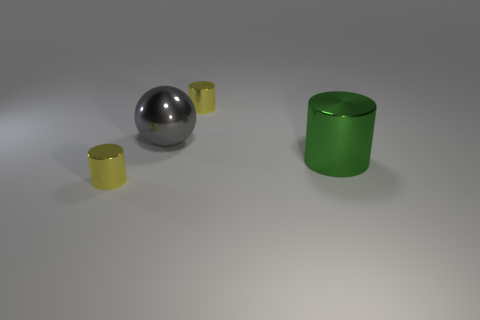Subtract all green spheres. Subtract all green cubes. How many spheres are left? 1 Add 1 tiny green matte cubes. How many objects exist? 5 Subtract all cylinders. How many objects are left? 1 Subtract 0 gray cylinders. How many objects are left? 4 Subtract all big red cylinders. Subtract all large gray things. How many objects are left? 3 Add 2 green metallic cylinders. How many green metallic cylinders are left? 3 Add 2 tiny cylinders. How many tiny cylinders exist? 4 